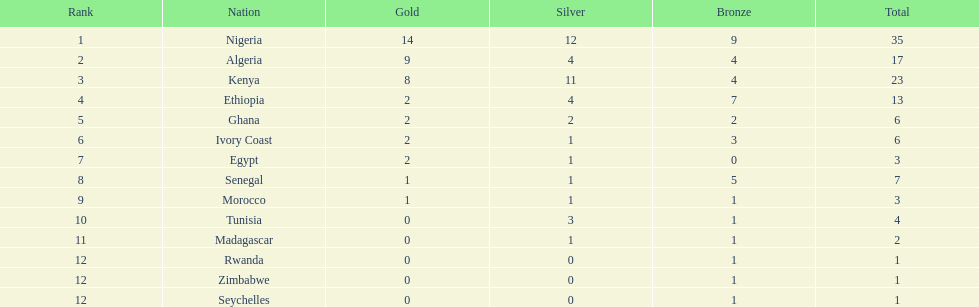What is the appellation of the primary nation displayed on this chart? Nigeria. I'm looking to parse the entire table for insights. Could you assist me with that? {'header': ['Rank', 'Nation', 'Gold', 'Silver', 'Bronze', 'Total'], 'rows': [['1', 'Nigeria', '14', '12', '9', '35'], ['2', 'Algeria', '9', '4', '4', '17'], ['3', 'Kenya', '8', '11', '4', '23'], ['4', 'Ethiopia', '2', '4', '7', '13'], ['5', 'Ghana', '2', '2', '2', '6'], ['6', 'Ivory Coast', '2', '1', '3', '6'], ['7', 'Egypt', '2', '1', '0', '3'], ['8', 'Senegal', '1', '1', '5', '7'], ['9', 'Morocco', '1', '1', '1', '3'], ['10', 'Tunisia', '0', '3', '1', '4'], ['11', 'Madagascar', '0', '1', '1', '2'], ['12', 'Rwanda', '0', '0', '1', '1'], ['12', 'Zimbabwe', '0', '0', '1', '1'], ['12', 'Seychelles', '0', '0', '1', '1']]} 